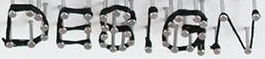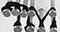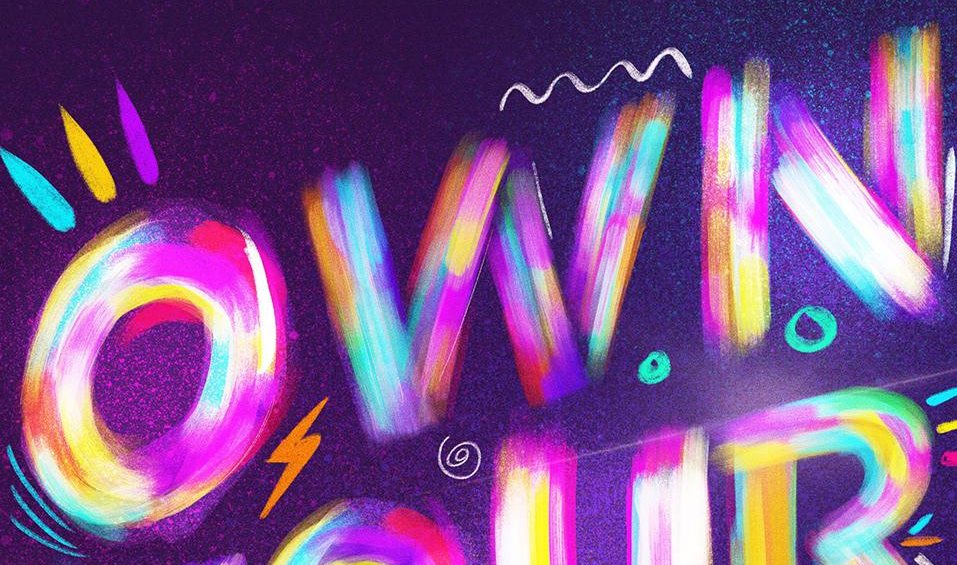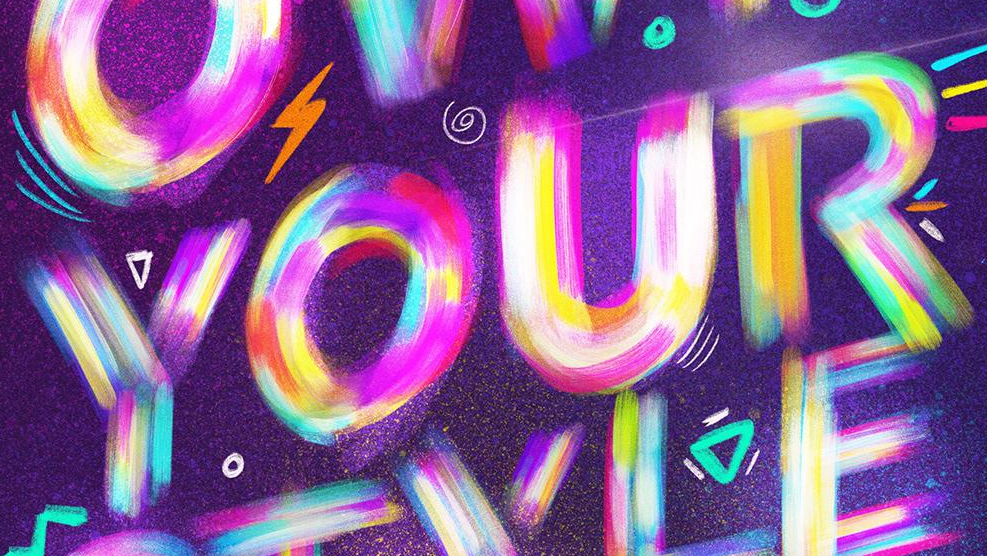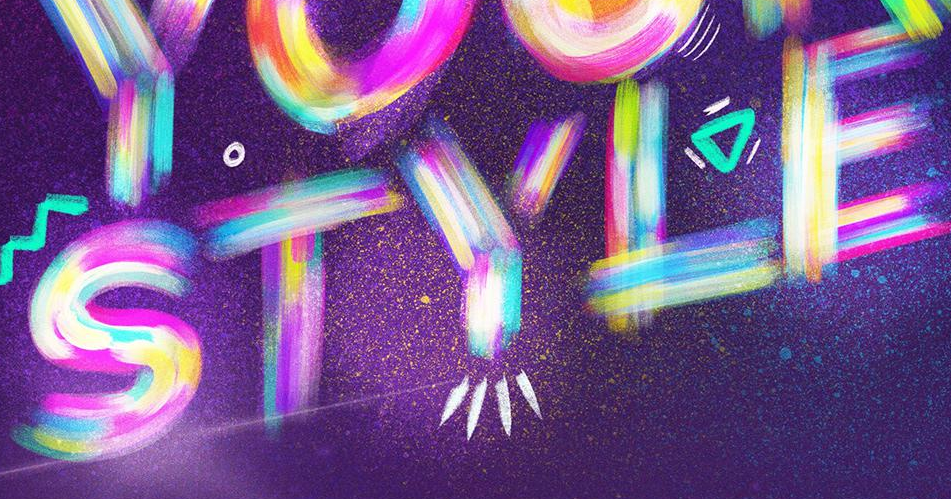What text is displayed in these images sequentially, separated by a semicolon? DESIGN; TM; OWN; YOUR; STYLE 